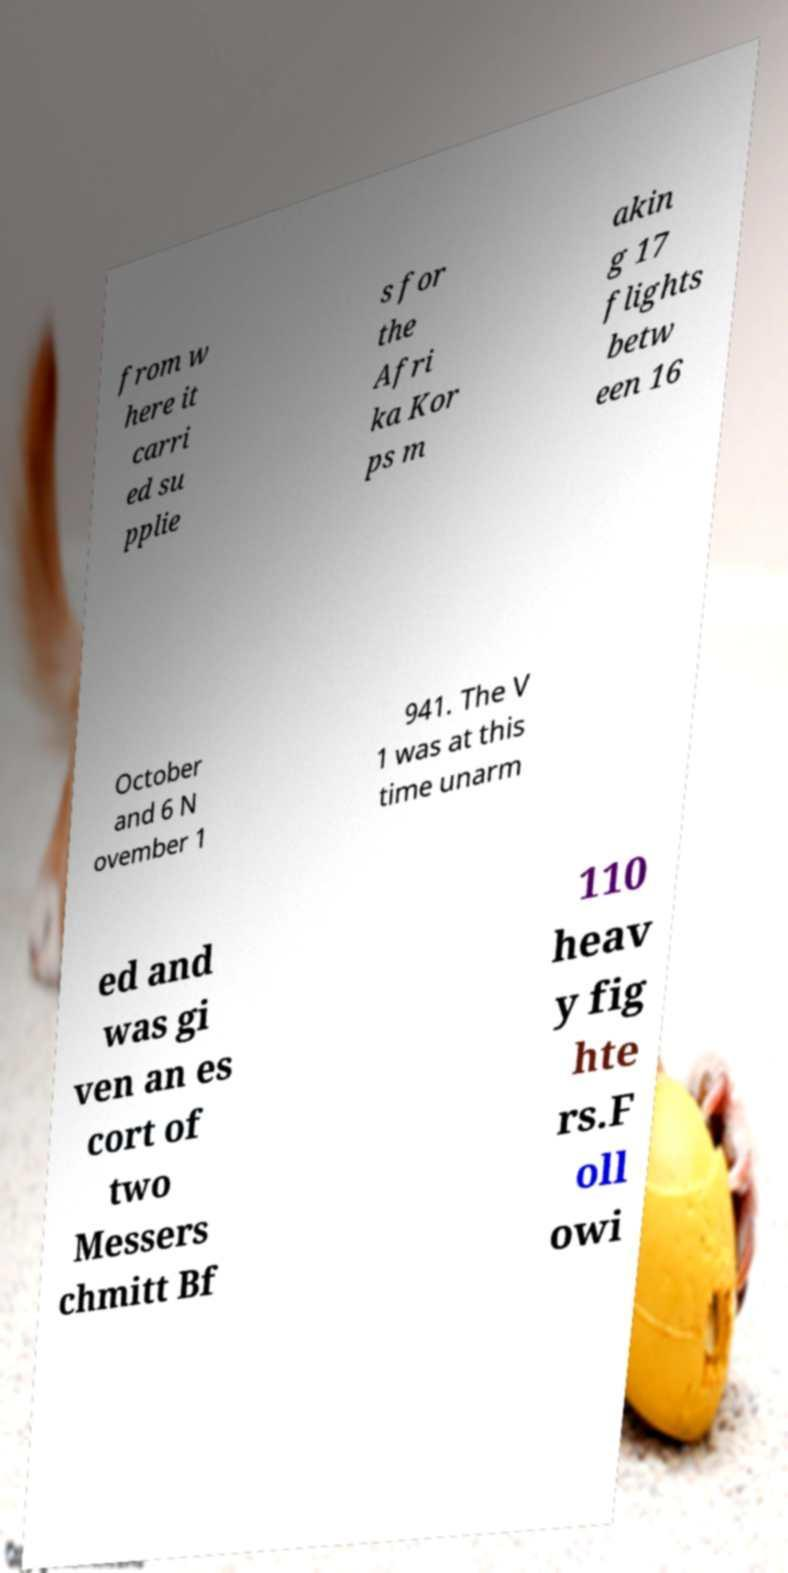Please read and relay the text visible in this image. What does it say? from w here it carri ed su pplie s for the Afri ka Kor ps m akin g 17 flights betw een 16 October and 6 N ovember 1 941. The V 1 was at this time unarm ed and was gi ven an es cort of two Messers chmitt Bf 110 heav y fig hte rs.F oll owi 